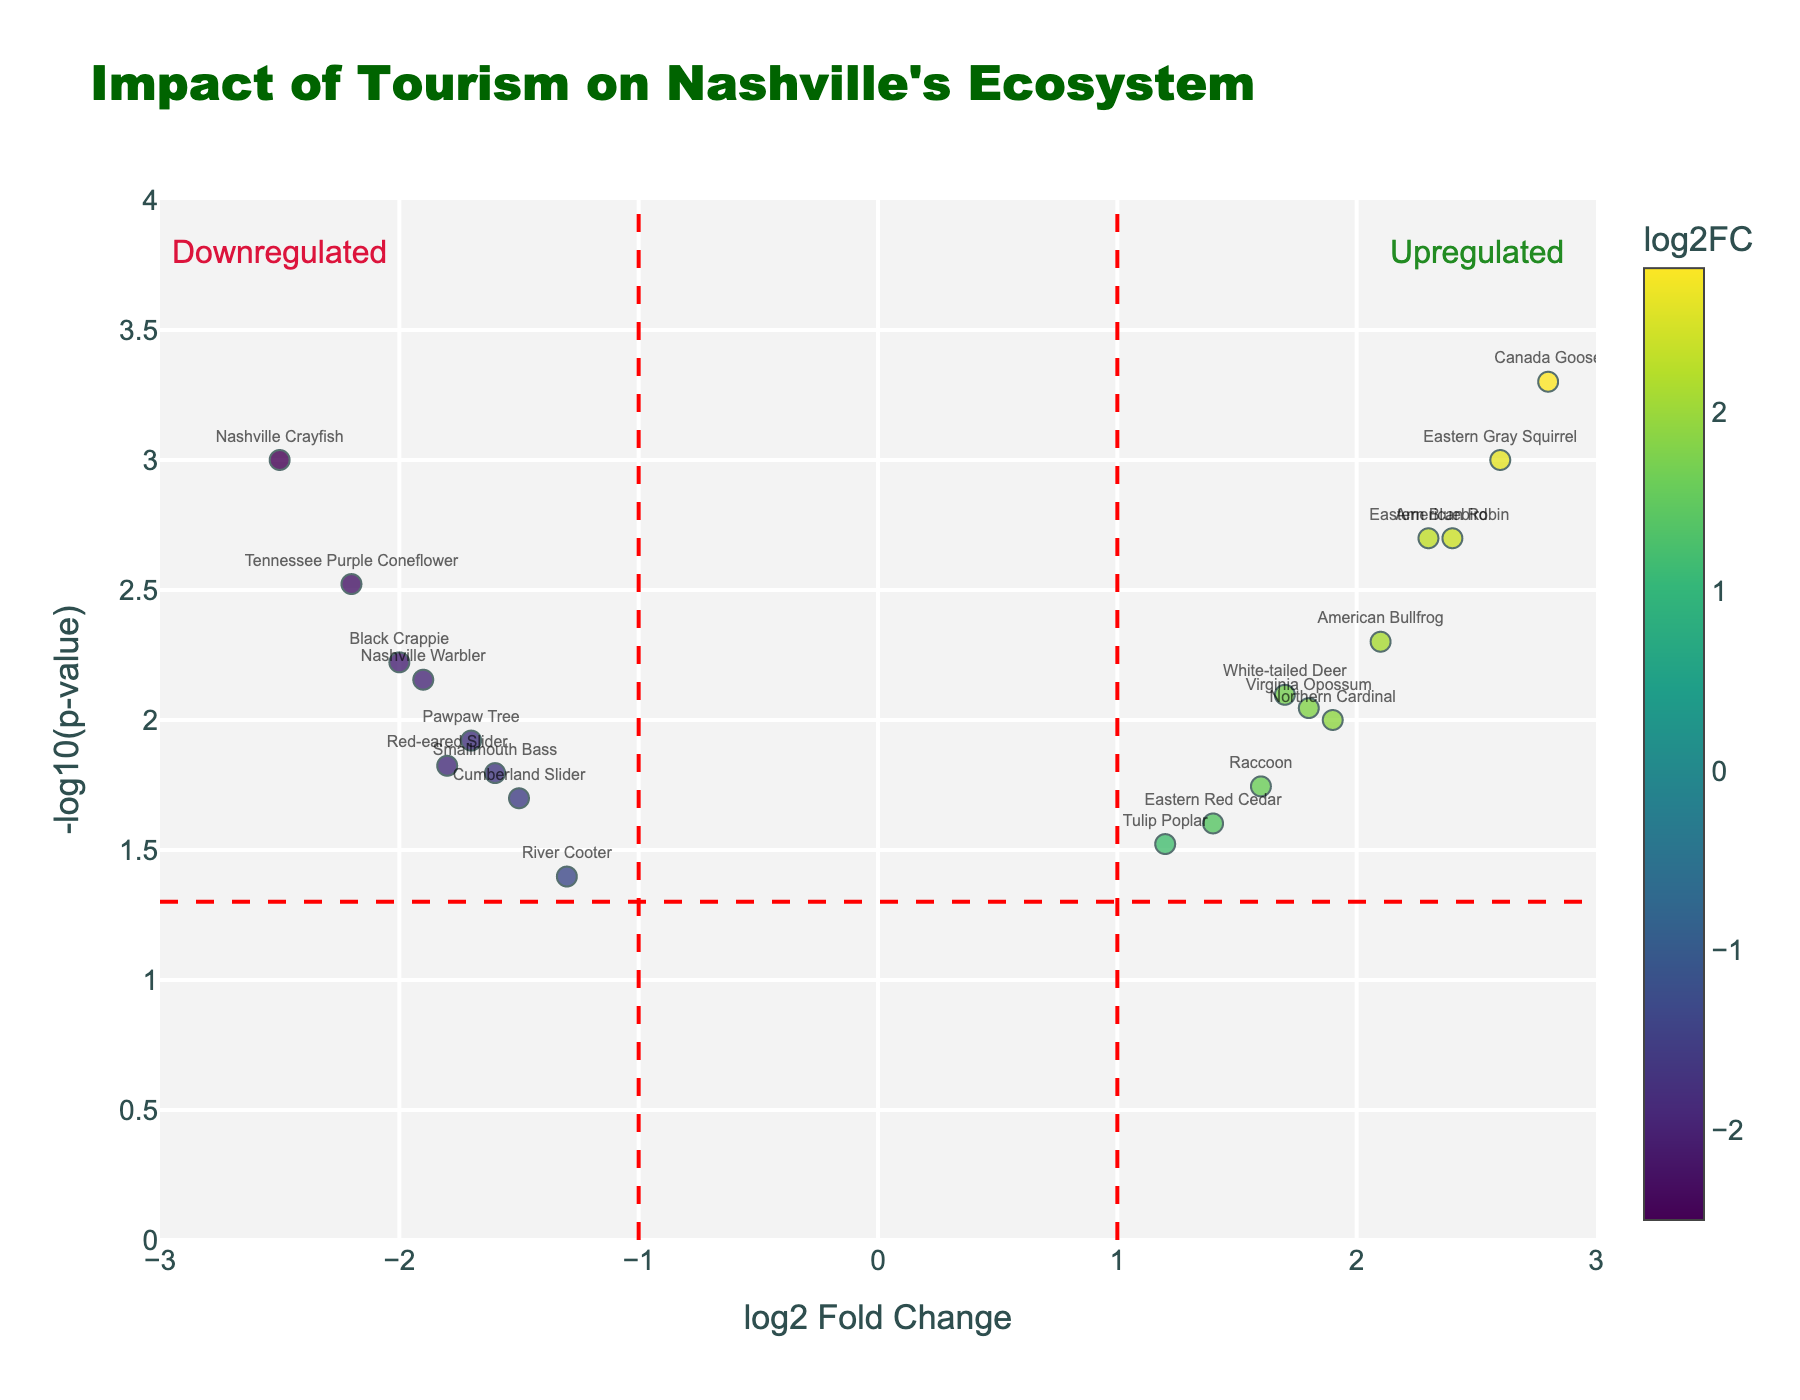What is the title of this plot? The title is located at the top of the plot, usually in a larger and more prominent font than other text. It directly states the purpose of the visualization.
Answer: "Impact of Tourism on Nashville's Ecosystem" How many species were observed to be upregulated? Upregulated species have a positive log2 Fold Change (log2FC) and are thus positioned to the right of the vertical line at x=1. By counting those data points visually, it is possible to reach the answer.
Answer: 9 Which species has the highest log2 Fold Change (log2FC)? Identify the species that lies furthest to the right on the x-axis. The highest positive log2FC determines this species.
Answer: Canada Goose Which species has the most significant downregulation? Downregulation is indicated by a negative log2FC, so we look for the lowest log2FC value (furthest to the left on the x-axis). The species corresponding to that data point is the answer.
Answer: Nashville Crayfish Which species has the smallest p-value? The p-value is inversely proportional to -log10(p-value), so the highest point on the y-axis will correspond to the smallest p-value. Identify the species at this highest point.
Answer: Canada Goose How many species have p-values less than 0.01? A p-value less than 0.01 corresponds to points above the horizontal threshold line at y = 2 on the plot (since -log10(0.01) = 2). Count the number of points above this line.
Answer: 10 Are there more species upregulated or downregulated based on the significant p-value threshold? First, find the number of species above the horizontal red line (p-value < 0.05) for both upregulated (right) and downregulated (left) sides. Compare these two counts.
Answer: More upregulated Which species shows significant regulation but is closest to neutral (log2FC = 0)? Look for points above the horizontal red line at y = 2 closest to the vertical axis (log2FC = 0). Calculate the distance from zero to find the closest among these points.
Answer: River Cooter What is the log2FC of the Eastern Gray Squirrel? Locate the data point for the Eastern Gray Squirrel and read its x-axis value, which represents the log2 Fold Change.
Answer: 2.6 Explain the criteria used for showing significant impact on the plot. Significant impacts are shown using threshold lines: a vertical line at log2FC = ±1 for fold change and a horizontal line at -log10(p-value) = 1.3 (p-value = 0.05). Data points beyond these thresholds are considered significant.
Answer: log2FC ≥ ±1, p-value < 0.05 